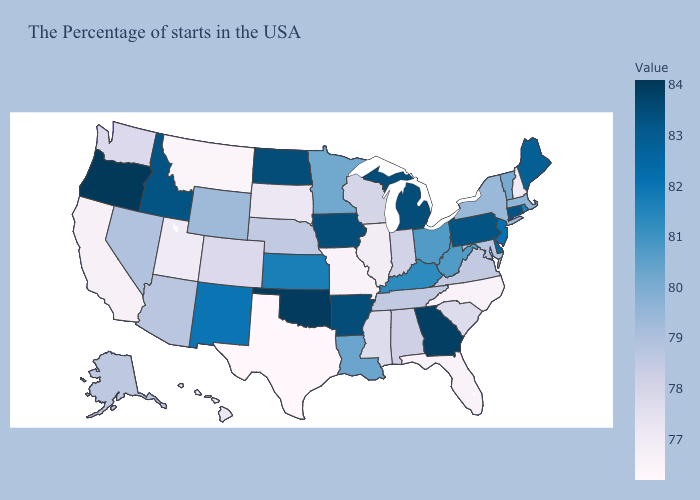Does the map have missing data?
Be succinct. No. Does Nebraska have the highest value in the MidWest?
Give a very brief answer. No. Does Alaska have the highest value in the West?
Answer briefly. No. Does Illinois have a lower value than Minnesota?
Quick response, please. Yes. Does the map have missing data?
Write a very short answer. No. 